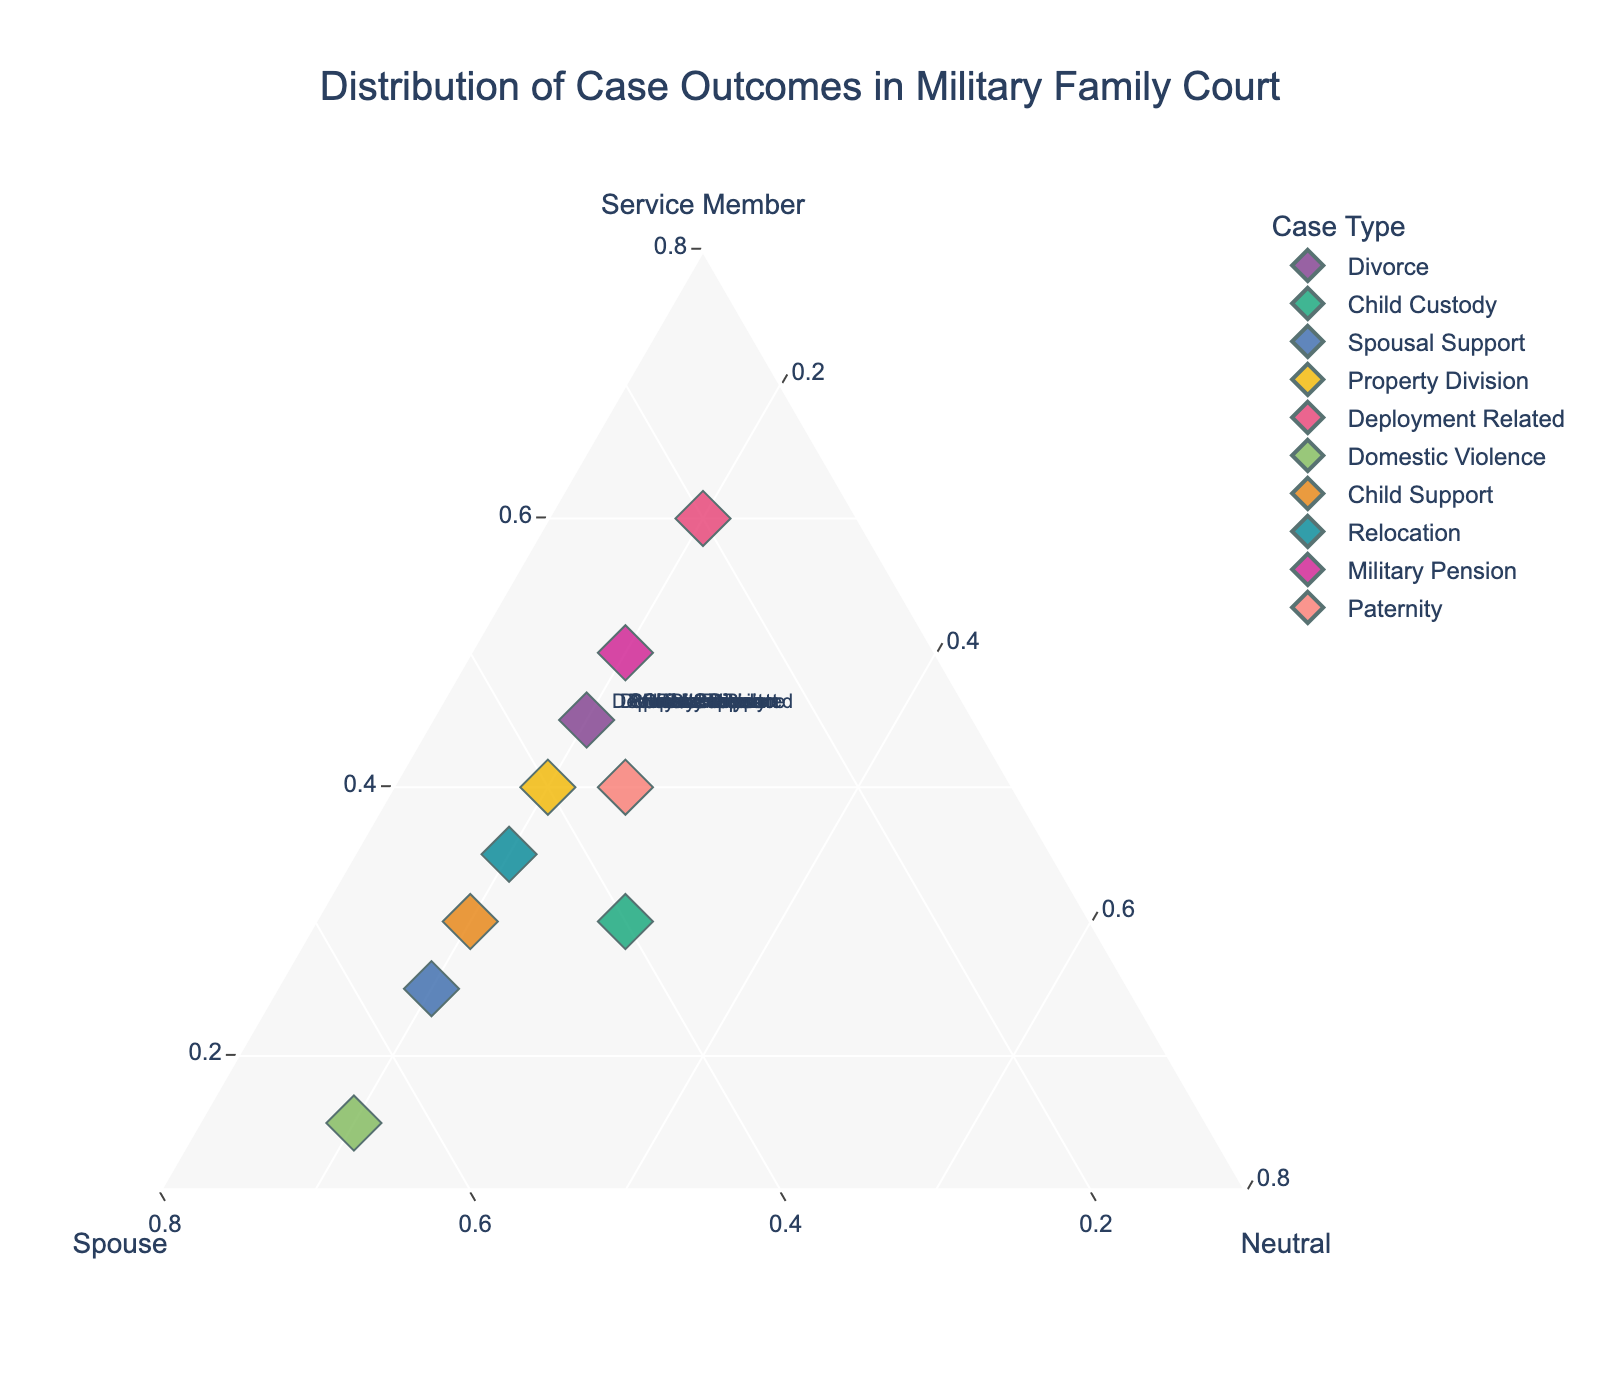what is the title of the figure? The title is usually located at the top of the figure in a larger font. In this case, it is found there as well.
Answer: Distribution of Case Outcomes in Military Family Court how many case types are presented in the ternary plot? Count the number of data points, which correspond to the different case types indicated by distinct colors and labels.
Answer: 10 which case type has the highest outcome percentage favorable to the service member? Examine the ternary plot for the point closest to the "Service Member" vertex, which represents the highest percentage for service members.
Answer: Deployment Related what is the percentage outcome for the spouse in domestic violence cases? Find the point labeled "Domestic Violence," and then look at its position relative to the "Spouse" axis.
Answer: 65% which case types have an equal percentage outcome for both the service member and the spouse? Look for points where the values for "Service Member" and "Spouse" are equal.
Answer: Child Custody, Property Division compare the percentage outcomes favorable to the spouse between divorce and child support cases. Identify the points for "Divorce" and "Child Support," then compare their positions relative to the "Spouse" axis.
Answer: 35% (Divorce) vs. 50% (Child Support) what are the average percentages for neutral outcomes across all case types? Sum the "Neutral" percentages for all case types and divide by the number of case types (10).
Answer: (20 + 30 + 20 + 20 + 20 + 20 + 20 + 20 + 20 + 25) / 10 = 21.5% which case type exhibits the most balanced outcome distribution? Look for the point closest to the center of the ternary plot, indicating similar values for service member, spouse, and neutral.
Answer: Child Custody in which case type does the spouse have the highest percentage outcome compared to others? Identify the point farthest away from the "Spouse" vertex.
Answer: Domestic Violence what percentage of outcomes in paternity cases are neutral? Find the point labeled "Paternity" and check its position relative to the "Neutral" axis.
Answer: 25% 